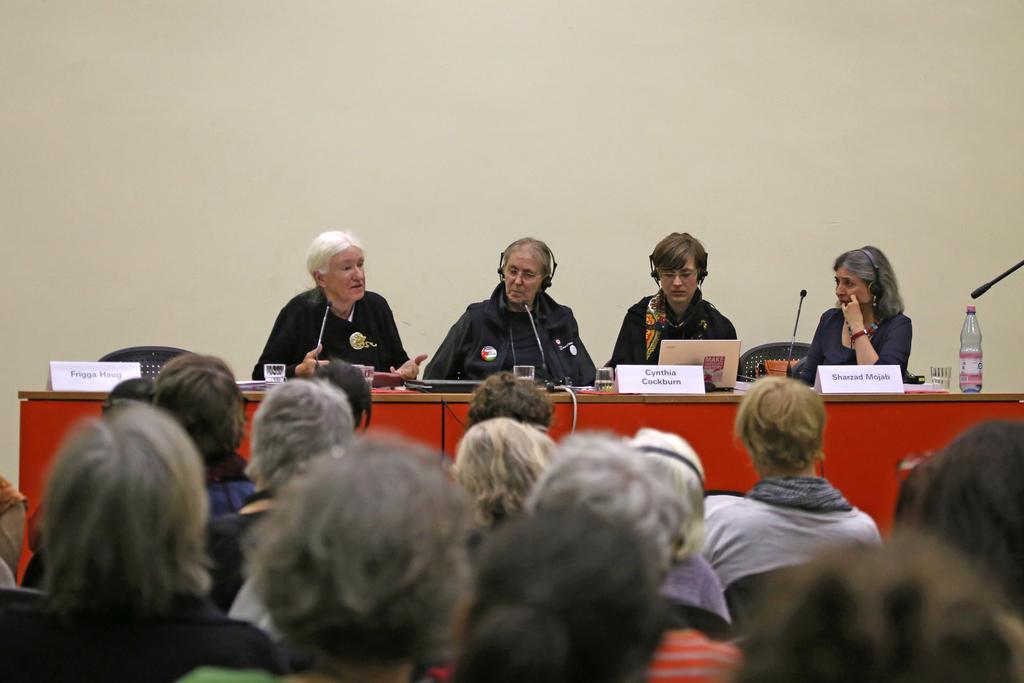Describe this image in one or two sentences. This image is taken indoors. In the background there is a wall. At the bottom of the image a few people are sitting on a chair. In the middle of the image there is a table with a few name boards, a few glasses, a bottle and a few things on it. Four people are sitting on the chairs and there is an empty chair. 